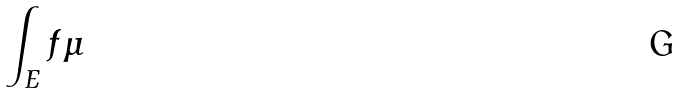Convert formula to latex. <formula><loc_0><loc_0><loc_500><loc_500>\int _ { E } f \mu</formula> 